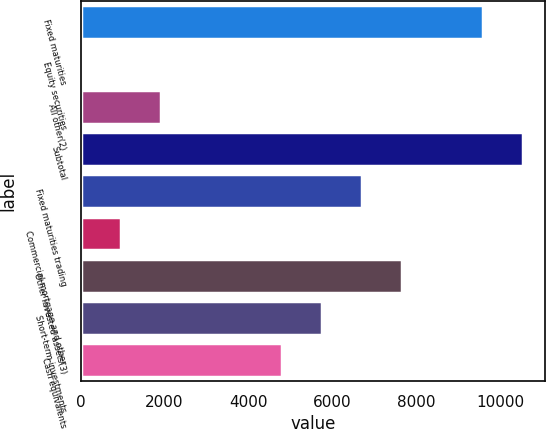Convert chart. <chart><loc_0><loc_0><loc_500><loc_500><bar_chart><fcel>Fixed maturities<fcel>Equity securities<fcel>All other(2)<fcel>Subtotal<fcel>Fixed maturities trading<fcel>Commercial mortgage and other<fcel>Other invested assets(3)<fcel>Short-term investments<fcel>Cash equivalents<nl><fcel>9577<fcel>1<fcel>1916.2<fcel>10534.6<fcel>6704.2<fcel>958.6<fcel>7661.8<fcel>5746.6<fcel>4789<nl></chart> 